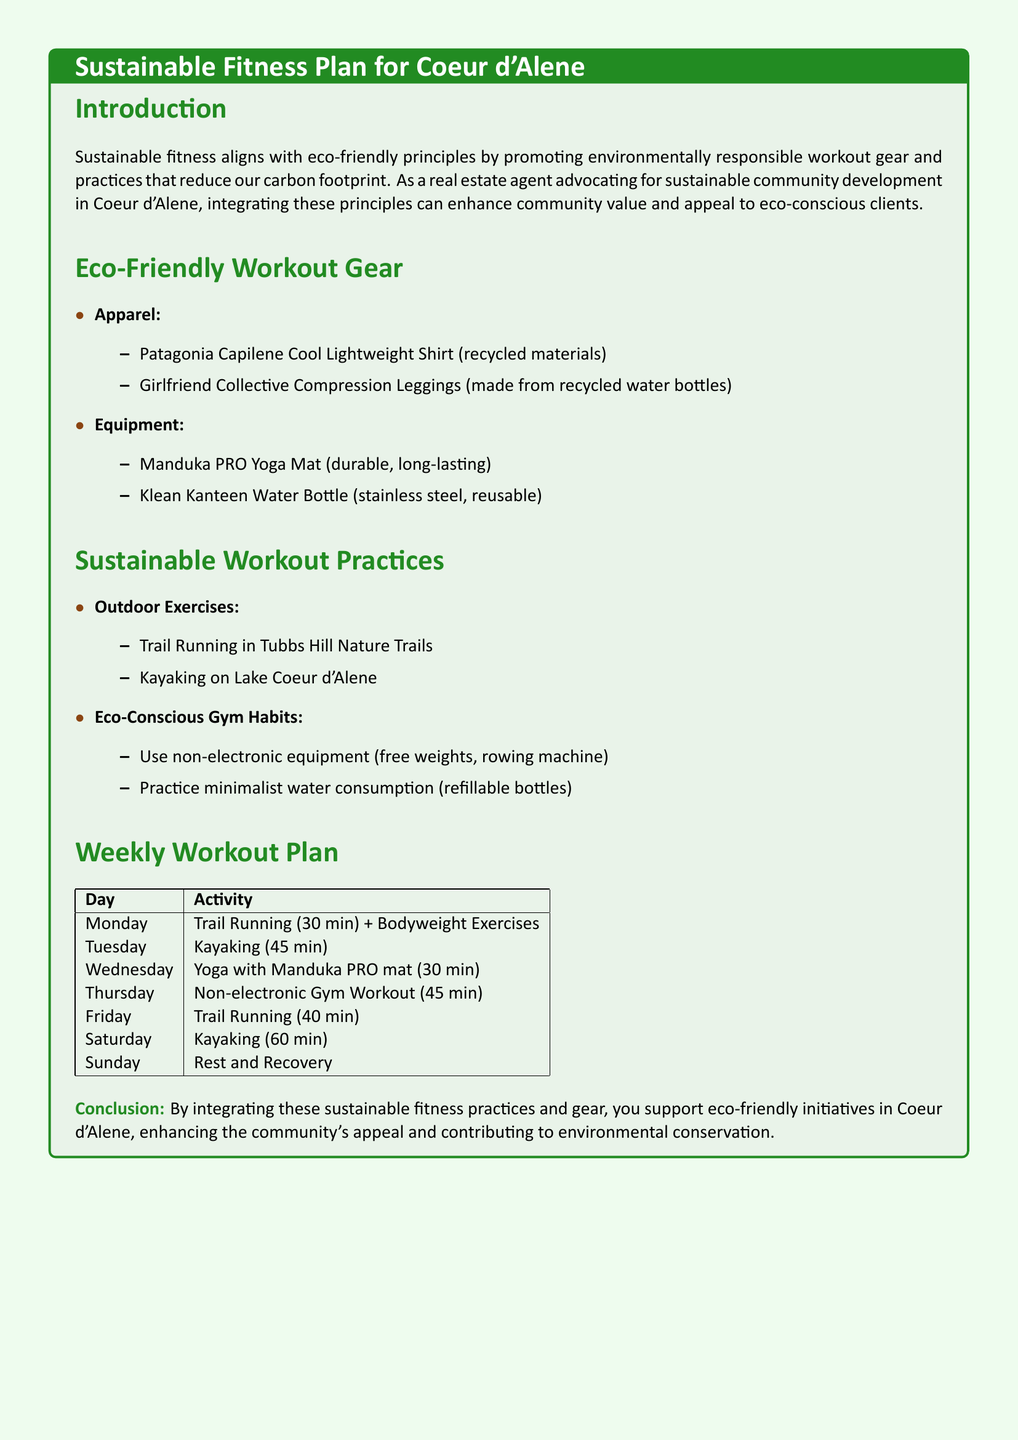What is the sustainable fitness plan for Coeur d'Alene? The document outlines an eco-friendly approach to fitness that focuses on sustainable practices and gear.
Answer: Sustainable Fitness Plan for Coeur d'Alene Which apparel is made from recycled materials? The document lists a specific shirt that uses recycled materials for its construction.
Answer: Patagonia Capilene Cool Lightweight Shirt What is the duration of kayaking on Tuesday? The workout plan specifies the time allocated for kayaking on Tuesday.
Answer: 45 min What type of equipment is recommended for outdoor exercises? The document provides suggestions for exercises that can be done outdoors, highlighting specific activities.
Answer: Trail Running, Kayaking What day includes yoga practice? The workout plan outlines specific activities for each day, naming the day when yoga is featured.
Answer: Wednesday Which brand produces a durable yoga mat? The document mentions a particular brand known for its long-lasting yoga mat.
Answer: Manduka What is the total workout duration for running activities in the week? The workout plan outlines several running sessions, requiring calculation of the total time spent running.
Answer: 70 min What provides a sustainable option for water consumption during workouts? The document emphasizes a specific type of bottle designed for eco-friendly hydration.
Answer: Refillable bottles 